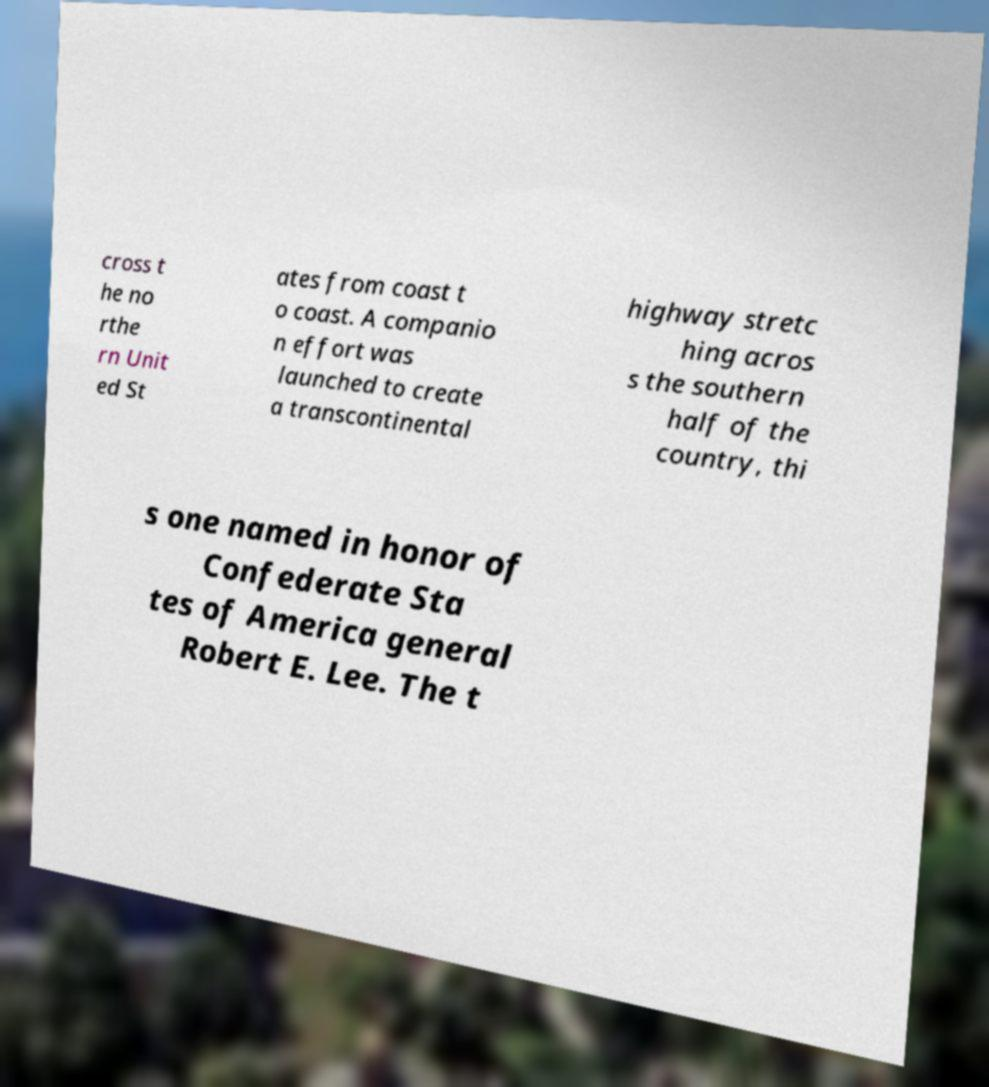Please read and relay the text visible in this image. What does it say? cross t he no rthe rn Unit ed St ates from coast t o coast. A companio n effort was launched to create a transcontinental highway stretc hing acros s the southern half of the country, thi s one named in honor of Confederate Sta tes of America general Robert E. Lee. The t 